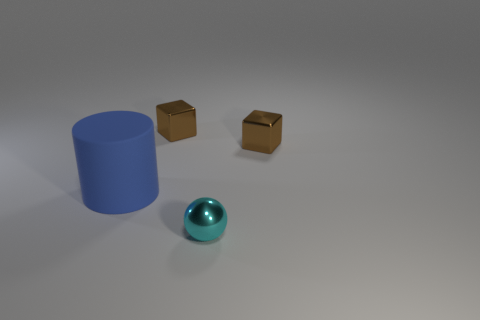Is there any other thing that has the same size as the blue matte cylinder?
Your answer should be compact. No. Is there any other thing that has the same material as the blue thing?
Provide a short and direct response. No. What number of blue things are small matte things or small metallic spheres?
Provide a succinct answer. 0. Are there any brown metal things that have the same size as the cyan ball?
Your answer should be compact. Yes. There is a small brown thing that is to the left of the small cyan metallic object to the right of the small brown metallic cube to the left of the cyan shiny ball; what is its material?
Provide a short and direct response. Metal. Are there an equal number of cyan things that are on the left side of the big blue object and red rubber cylinders?
Your answer should be compact. Yes. Are the cylinder that is behind the shiny ball and the small brown block that is to the left of the tiny cyan metal thing made of the same material?
Provide a succinct answer. No. How many things are blue cylinders or tiny brown cubes that are to the right of the tiny ball?
Your answer should be very brief. 2. How big is the thing that is to the left of the tiny block on the left side of the small thing that is in front of the big blue rubber thing?
Give a very brief answer. Large. Are there the same number of objects that are to the right of the rubber cylinder and cylinders to the left of the cyan metallic ball?
Make the answer very short. No. 